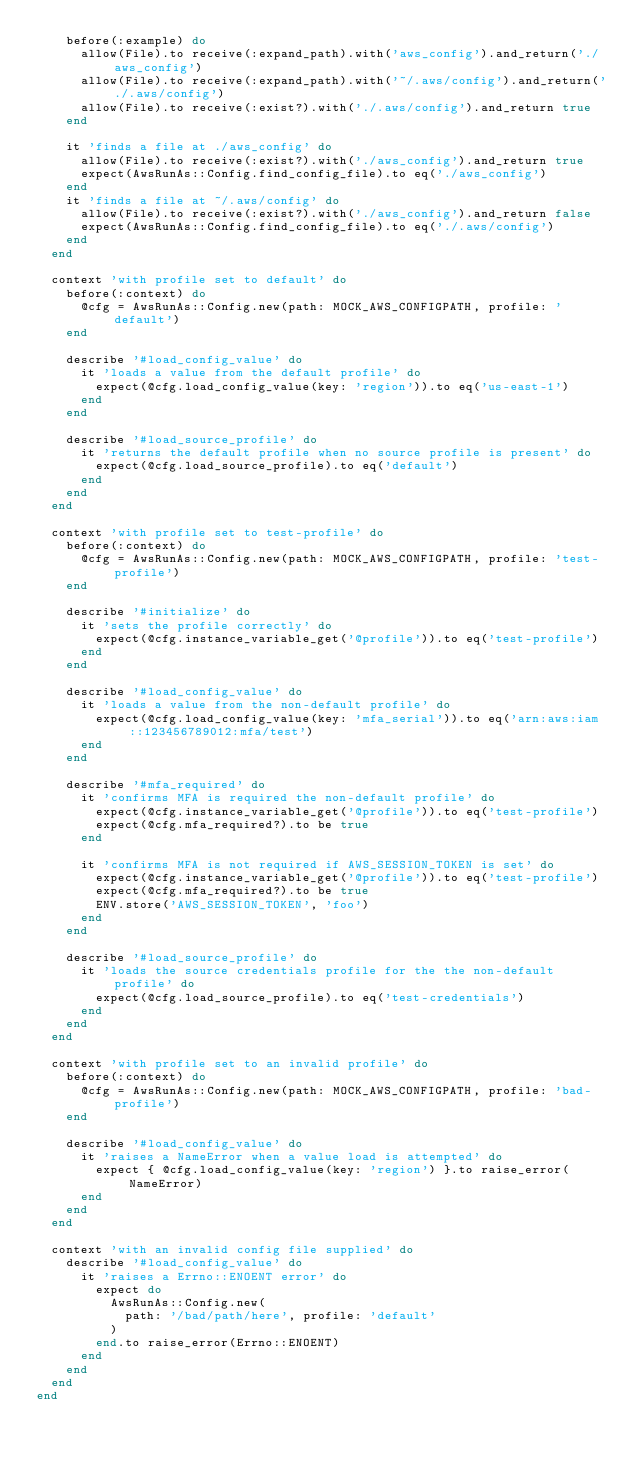<code> <loc_0><loc_0><loc_500><loc_500><_Ruby_>    before(:example) do
      allow(File).to receive(:expand_path).with('aws_config').and_return('./aws_config')
      allow(File).to receive(:expand_path).with('~/.aws/config').and_return('./.aws/config')
      allow(File).to receive(:exist?).with('./.aws/config').and_return true
    end

    it 'finds a file at ./aws_config' do
      allow(File).to receive(:exist?).with('./aws_config').and_return true
      expect(AwsRunAs::Config.find_config_file).to eq('./aws_config')
    end
    it 'finds a file at ~/.aws/config' do
      allow(File).to receive(:exist?).with('./aws_config').and_return false
      expect(AwsRunAs::Config.find_config_file).to eq('./.aws/config')
    end
  end

  context 'with profile set to default' do
    before(:context) do
      @cfg = AwsRunAs::Config.new(path: MOCK_AWS_CONFIGPATH, profile: 'default')
    end

    describe '#load_config_value' do
      it 'loads a value from the default profile' do
        expect(@cfg.load_config_value(key: 'region')).to eq('us-east-1')
      end
    end

    describe '#load_source_profile' do
      it 'returns the default profile when no source profile is present' do
        expect(@cfg.load_source_profile).to eq('default')
      end
    end
  end

  context 'with profile set to test-profile' do
    before(:context) do
      @cfg = AwsRunAs::Config.new(path: MOCK_AWS_CONFIGPATH, profile: 'test-profile')
    end

    describe '#initialize' do
      it 'sets the profile correctly' do
        expect(@cfg.instance_variable_get('@profile')).to eq('test-profile')
      end
    end

    describe '#load_config_value' do
      it 'loads a value from the non-default profile' do
        expect(@cfg.load_config_value(key: 'mfa_serial')).to eq('arn:aws:iam::123456789012:mfa/test')
      end
    end

    describe '#mfa_required' do
      it 'confirms MFA is required the non-default profile' do
        expect(@cfg.instance_variable_get('@profile')).to eq('test-profile')
        expect(@cfg.mfa_required?).to be true
      end

      it 'confirms MFA is not required if AWS_SESSION_TOKEN is set' do
        expect(@cfg.instance_variable_get('@profile')).to eq('test-profile')
        expect(@cfg.mfa_required?).to be true
        ENV.store('AWS_SESSION_TOKEN', 'foo')
      end
    end

    describe '#load_source_profile' do
      it 'loads the source credentials profile for the the non-default profile' do
        expect(@cfg.load_source_profile).to eq('test-credentials')
      end
    end
  end

  context 'with profile set to an invalid profile' do
    before(:context) do
      @cfg = AwsRunAs::Config.new(path: MOCK_AWS_CONFIGPATH, profile: 'bad-profile')
    end

    describe '#load_config_value' do
      it 'raises a NameError when a value load is attempted' do
        expect { @cfg.load_config_value(key: 'region') }.to raise_error(NameError)
      end
    end
  end

  context 'with an invalid config file supplied' do
    describe '#load_config_value' do
      it 'raises a Errno::ENOENT error' do
        expect do
          AwsRunAs::Config.new(
            path: '/bad/path/here', profile: 'default'
          )
        end.to raise_error(Errno::ENOENT)
      end
    end
  end
end
</code> 